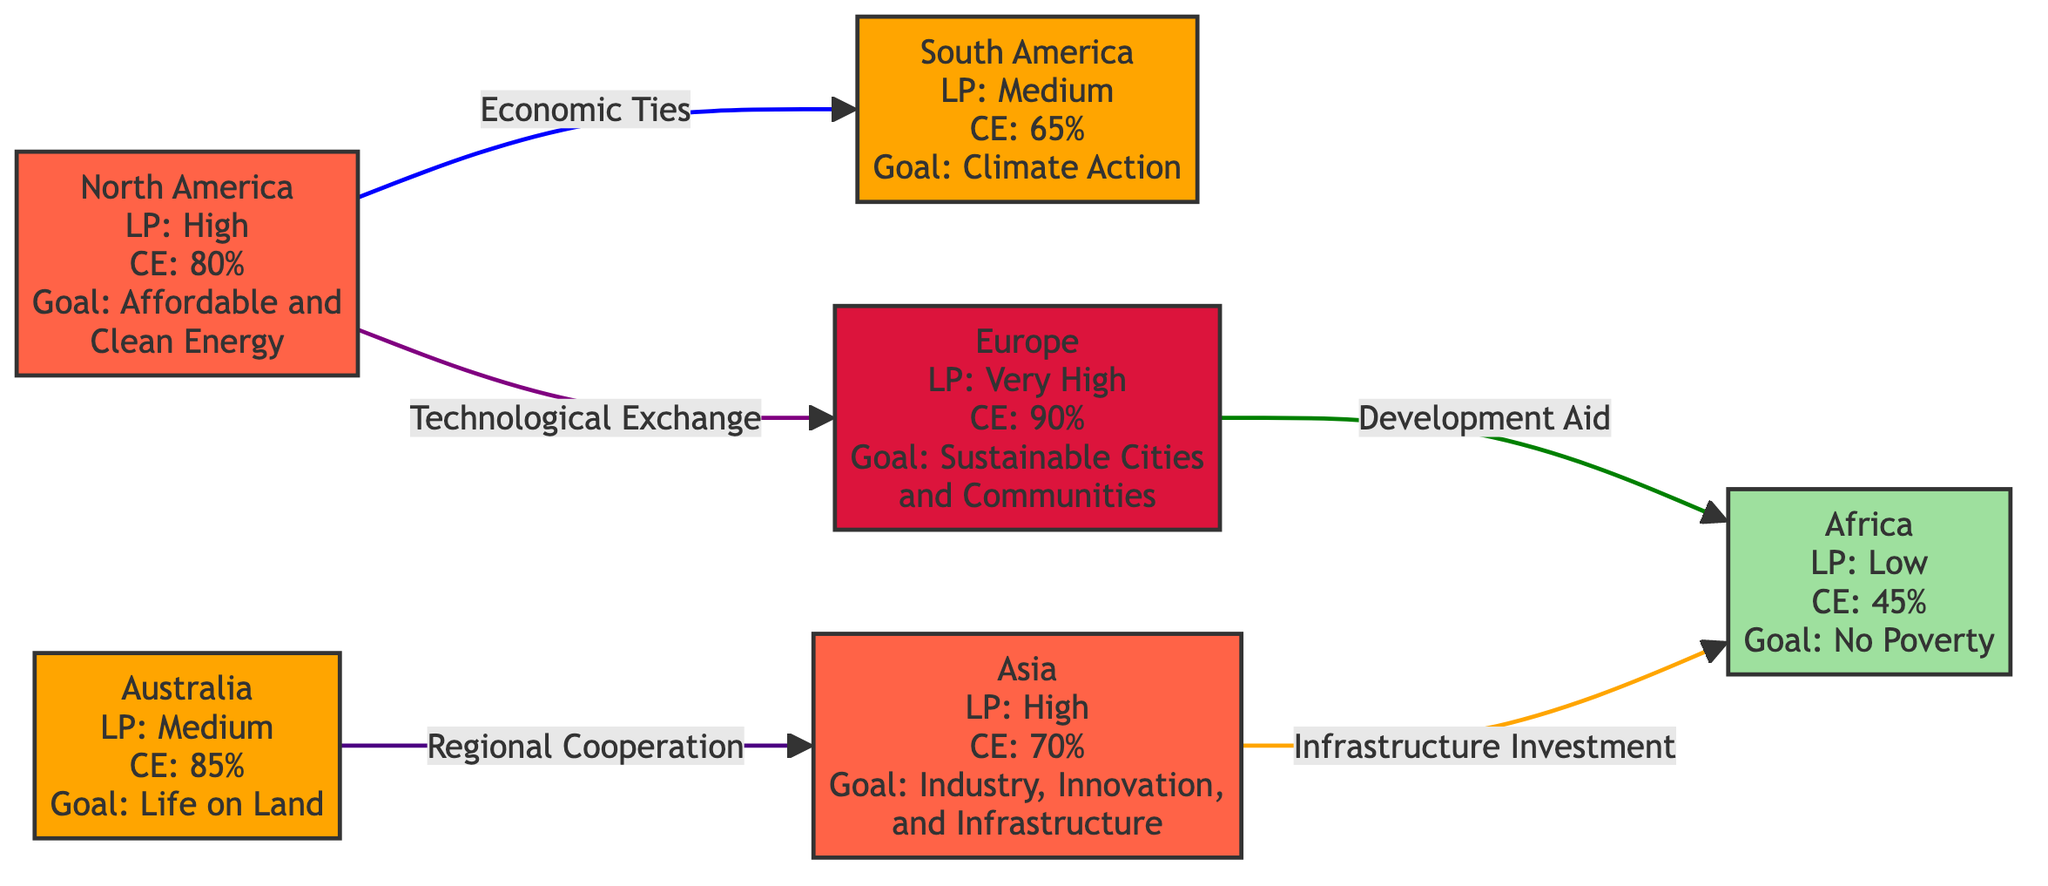What is the light pollution level in Europe? According to the diagram, Europe is marked with "LP: Very High," indicating the level of light pollution in that region.
Answer: Very High Which continent has the highest access to clean energy? The diagram specifies that Europe has the highest access to clean energy with "CE: 90%," when comparing the access to clean energy across all continents represented.
Answer: 90% What development goal is associated with Asia? By checking the relevant node for Asia, the diagram indicates that the associated goal is "Industry, Innovation, and Infrastructure."
Answer: Industry, Innovation, and Infrastructure How many continents have a medium level of light pollution? In the diagram, South America and Australia are classified with "Medium" light pollution levels, thus the total count is two.
Answer: 2 What type of cooperation exists between Australia and Asia? The diagram outlines that the nature of cooperation that exists between Australia and Asia is "Regional Cooperation."
Answer: Regional Cooperation What is the relationship type between North America and South America? The diagram describes the relationship between North America and South America as "Economic Ties," showing the nature of their connection.
Answer: Economic Ties Which continent has the lowest access to clean energy? Africa is indicated in the diagram with "CE: 45%," making it the continent with the lowest access to clean energy.
Answer: 45% How many edges connect to Africa? The diagram visually represents three connections (edges) arriving at Africa, specifically from Europe and Asia, thus the total is three.
Answer: 3 What type of development goal is linked to South America? According to the South America node, the associated development goal is "Climate Action," which is highlighted in the diagram.
Answer: Climate Action 